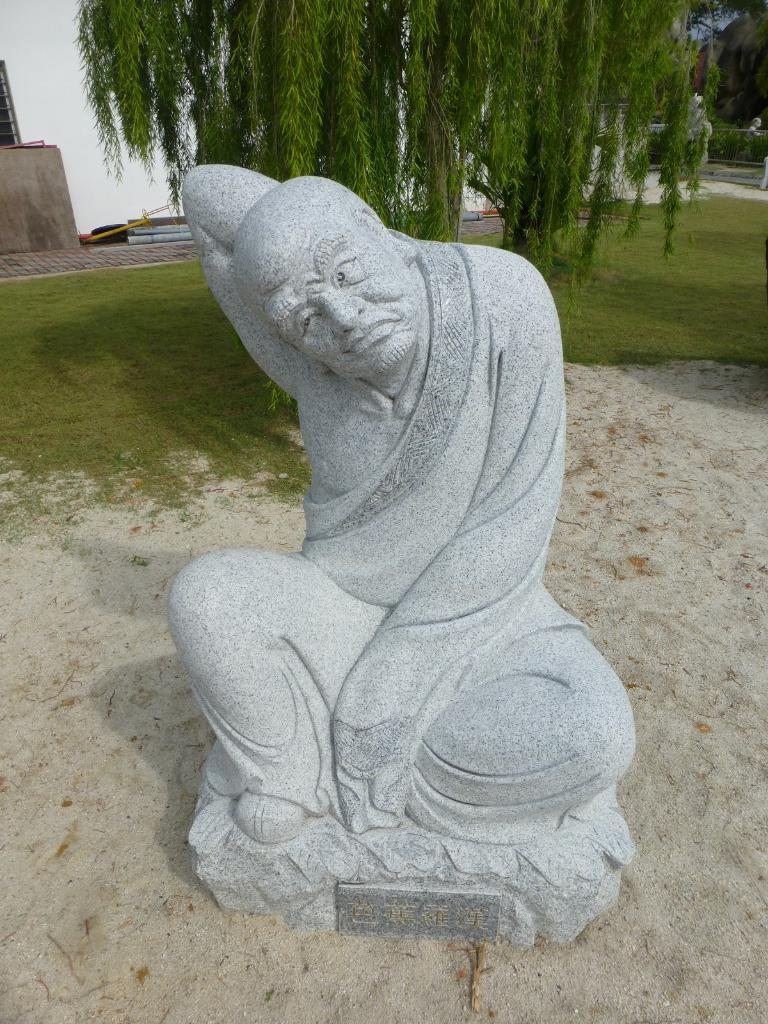What is the main subject in the center of the image? There is a sculpture in the center of the image. What can be seen in the background of the image? There is a tree and a building in the background of the image. What direction is the army marching towards in the image? There is no army present in the image, so it is not possible to determine the direction they might be marching. 